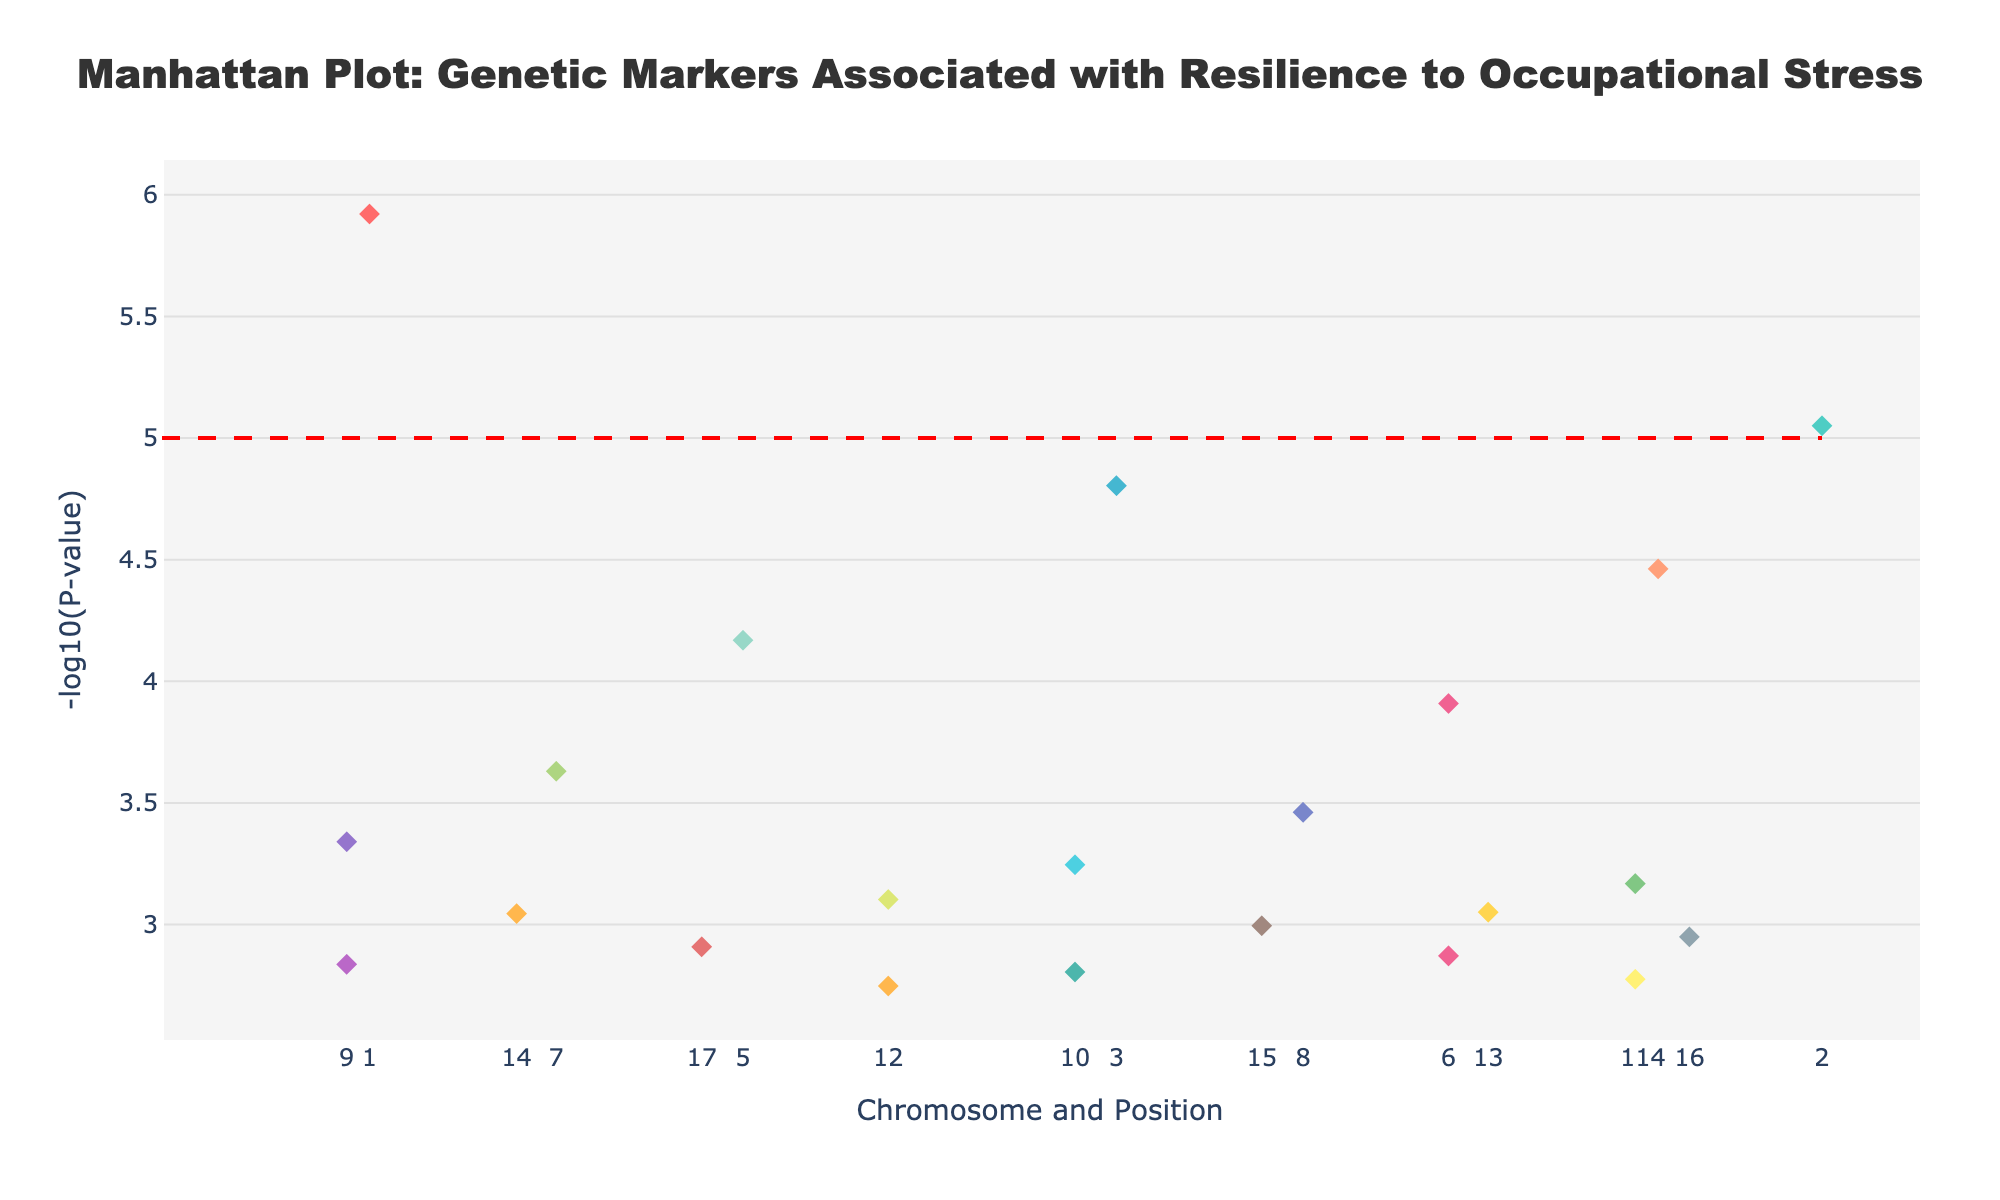What is the title of the plot? The title is located at the top of the plot and is a textual description that provides insight into what the plot represents. From the data provided, it can be stated as is.
Answer: Manhattan Plot: Genetic Markers Associated with Resilience to Occupational Stress What does the y-axis represent? The y-axis represents a transformed statistical measure. By definition in a Manhattan Plot relating to genetics, it shows the -log10(P-value), indicating the statistical significance of each genetic marker.
Answer: -log10(P-value) Which chromosome has the genetic marker with the lowest P-value? Identify the genetic marker with the lowest P-value by looking at the highest point on the y-axis and then trace it to the corresponding chromosome, labeled on the x-axis. In this case, the SNP rs4680 on chromosome 1 has the lowest P-value because it reaches the highest -log10(P-value).
Answer: Chromosome 1 How many SNPs are plotted for chromosome 7? Each chromosome has a distinct color and multiple points, representing SNPs. By counting the diamond markers along the x-axis at chromosome 7's position, we see there is 1 SNP plotted.
Answer: 1 Which SNP is associated with the highest P-value, and on which chromosome is it located? The highest P-value corresponds to the lowest point on the y-axis. Identify this lowest point and use the hover text or legend to determine the SNP and its chromosome. The SNP rs6277 on chromosome 22 has the highest P-value (0.0017890) and thus the lowest -log10(P-value).
Answer: rs6277, Chromosome 22 What is the significance threshold marked by the horizontal line? This threshold is commonly set in genetic studies to determine which markers are statistically significant. The horizontal line on the plot is at -log10(P-value) = 5, based on typical conventions (P-value = 5e-8).
Answer: 5 Compare the number of significant SNPs on chromosomes 1 and 4. Identify which points are above the significance threshold for both chromosomes by counting how many points cross the horizontal line at -log10(P-value) > 5 for each of the chromosomes. Chromosome 1 has 1 SNP (rs4680) and chromosome 4 has zero above the threshold.
Answer: Chromosome 1: 1, Chromosome 4: 0 What color represents chromosome 12, and how many SNPs are associated with it? Identify the distinct color used for chromosome 12 on the legend or by the unique colors in the plot. Based on the code, it specifically uses '#DCE775' which is yellowish. Count the corresponding points for accuracy.
Answer: Yellow, 1 SNP Which two chromosomes have identical SNPs named rs1799971, and what are their positions? Locate the SNP label, rs1799971, either from hover text or by referring to the unique label on multiple positions. Check the positions listed for rs1799971 in the data provided, which are under chromosome 4 (8901234) and chromosome 13 (7890123).
Answer: Chromosome 4: 8901234, Chromosome 13: 7890123 Are there any chromosomes without significant SNPs? Review each chromosome to determine if any points surpass the significance threshold line at -log10(P-value) > 5. If none do for a chromosome, it has no significant SNPs. Chromosome 4 does not have any SNPs above this line.
Answer: Yes, chromosome 4 